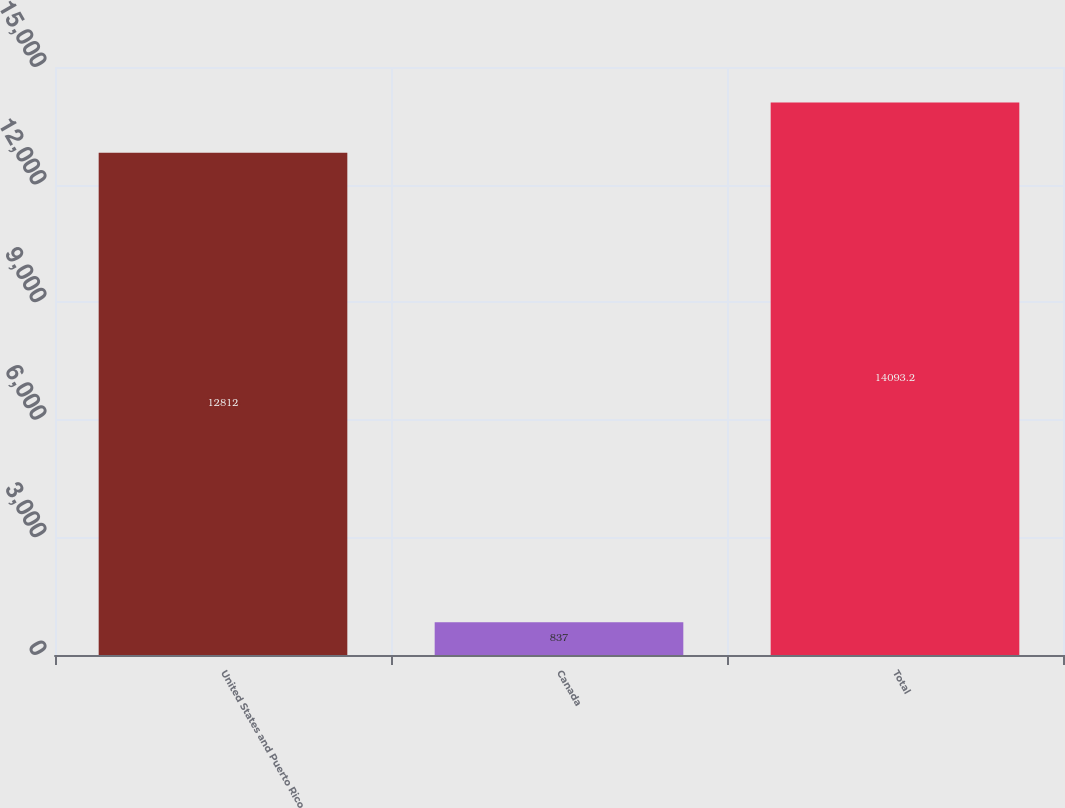Convert chart. <chart><loc_0><loc_0><loc_500><loc_500><bar_chart><fcel>United States and Puerto Rico<fcel>Canada<fcel>Total<nl><fcel>12812<fcel>837<fcel>14093.2<nl></chart> 